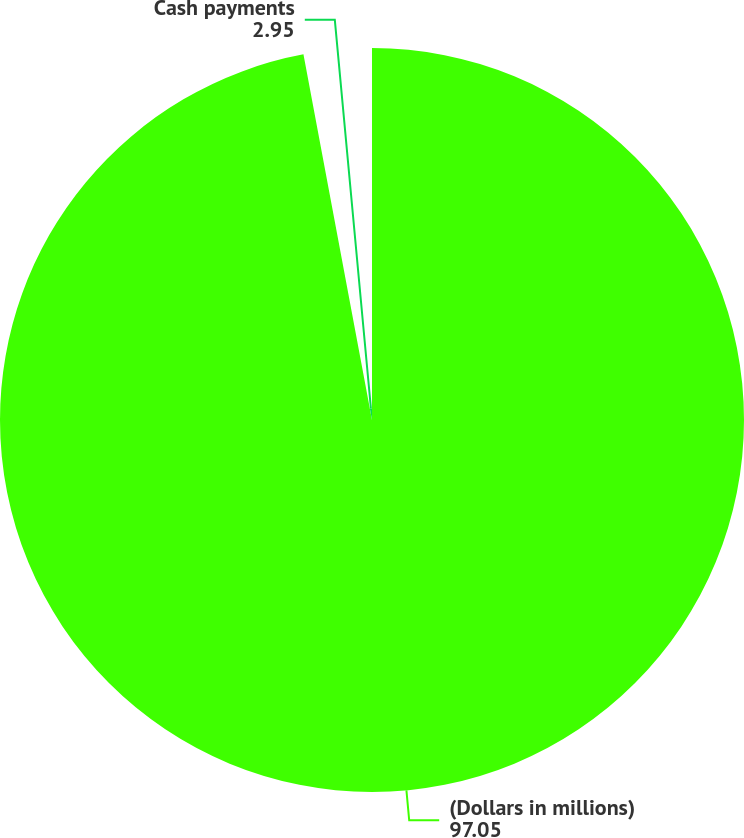Convert chart to OTSL. <chart><loc_0><loc_0><loc_500><loc_500><pie_chart><fcel>(Dollars in millions)<fcel>Cash payments<nl><fcel>97.05%<fcel>2.95%<nl></chart> 